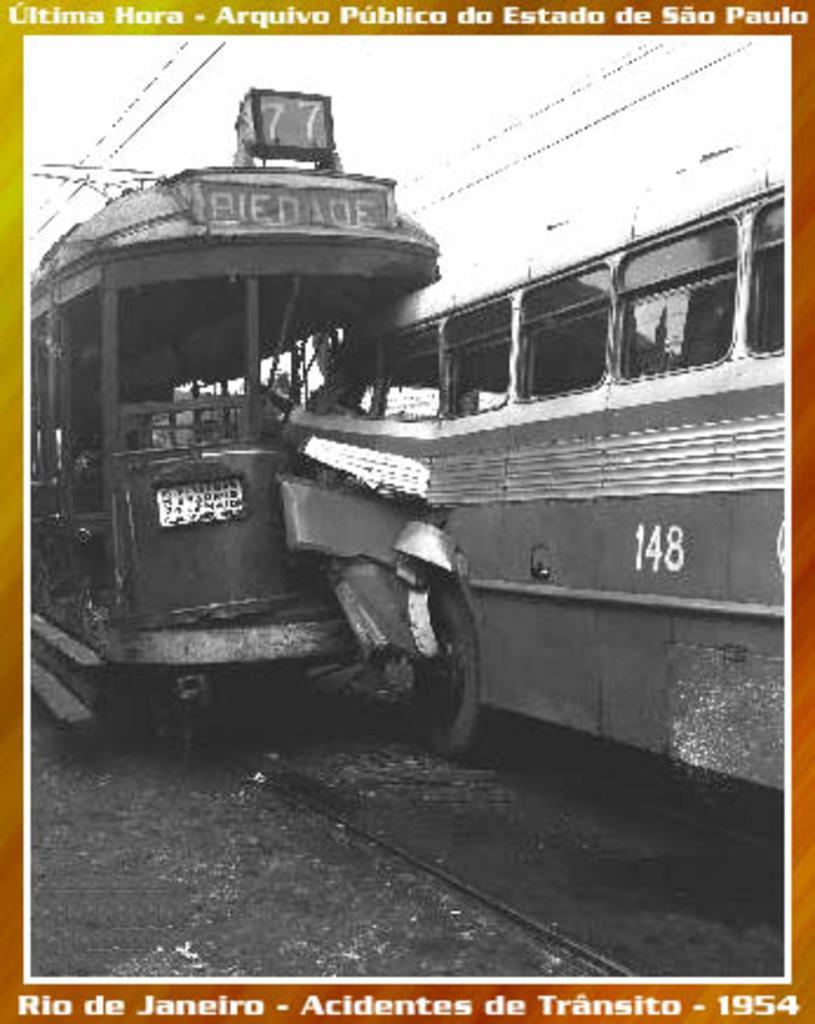In one or two sentences, can you explain what this image depicts? In this image we can see black and white pic on a poster. At the top and bottom we can see texts written on the poster. In the black and white pic we can see a vehicle hit the another vehicle. In the background we can see wires. 